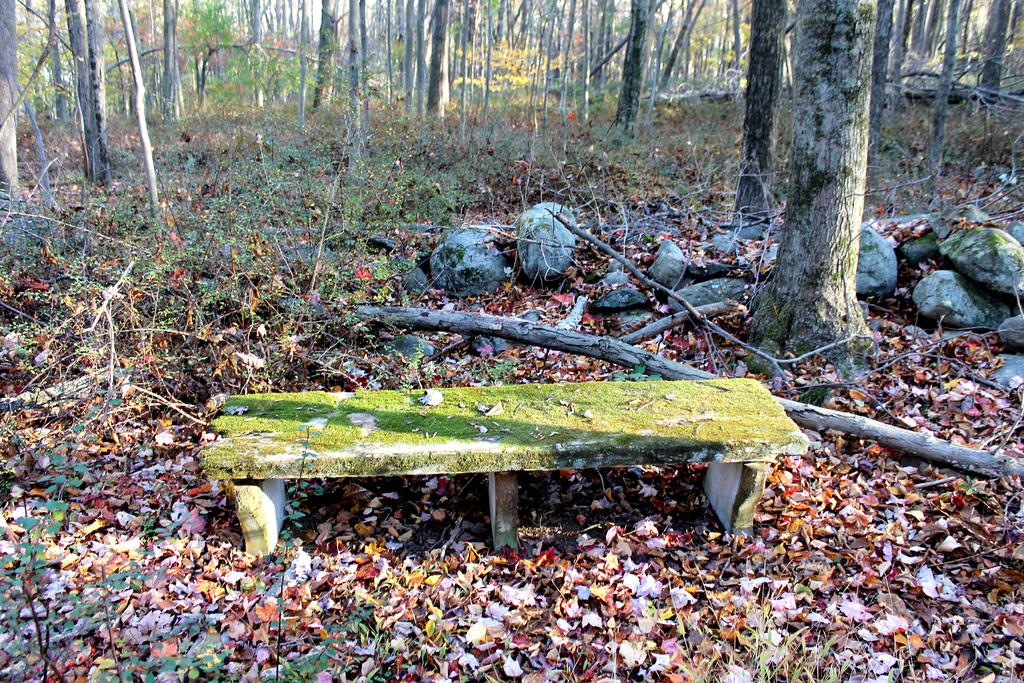What type of seating is visible in the image? There is a bench in the image. Where is the bench located? The bench is on a land. What can be seen in the background of the image? There are stones and trees in the background of the image. What type of celery is growing near the bench in the image? There is no celery present in the image. Is there a lock on the bench in the image? There is no lock visible on the bench in the image. 